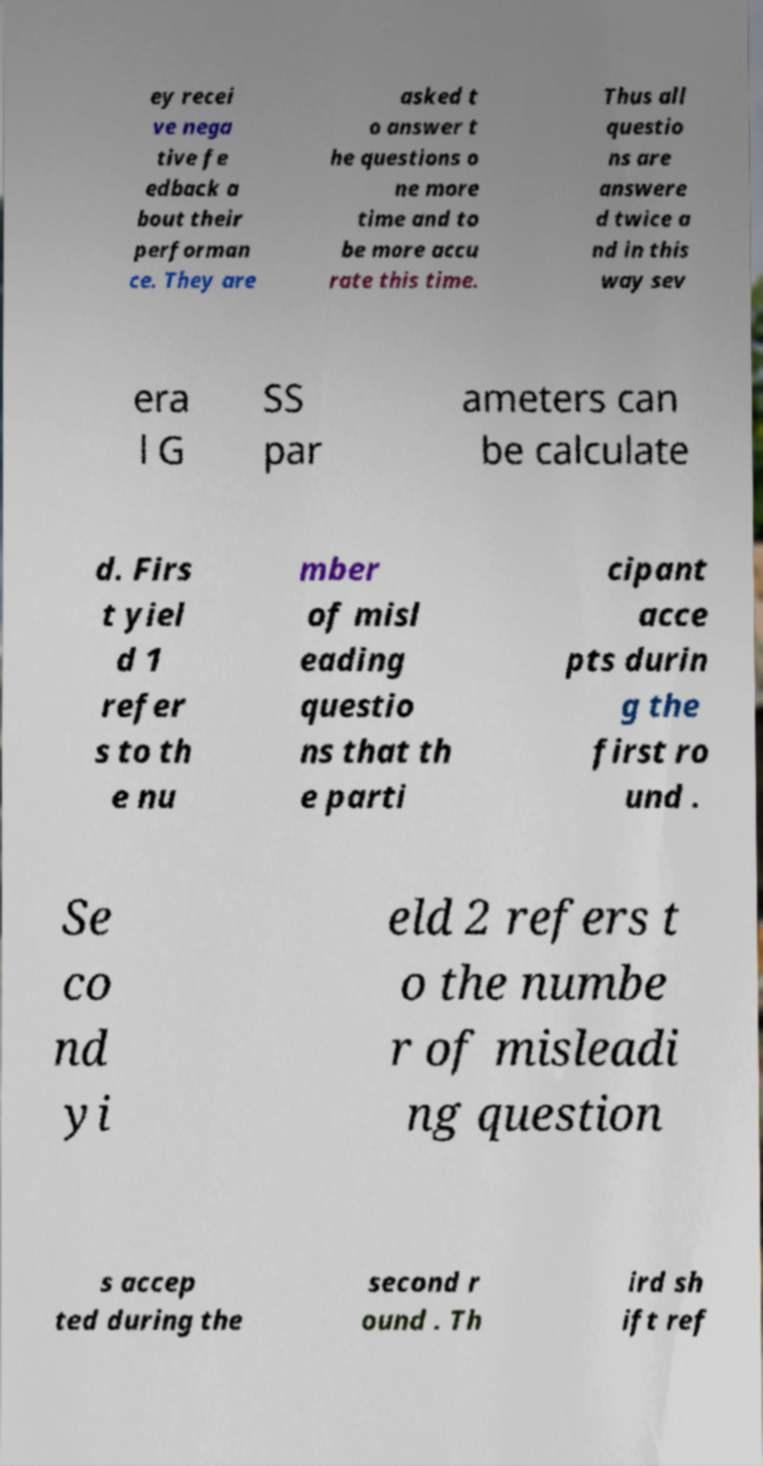For documentation purposes, I need the text within this image transcribed. Could you provide that? ey recei ve nega tive fe edback a bout their performan ce. They are asked t o answer t he questions o ne more time and to be more accu rate this time. Thus all questio ns are answere d twice a nd in this way sev era l G SS par ameters can be calculate d. Firs t yiel d 1 refer s to th e nu mber of misl eading questio ns that th e parti cipant acce pts durin g the first ro und . Se co nd yi eld 2 refers t o the numbe r of misleadi ng question s accep ted during the second r ound . Th ird sh ift ref 